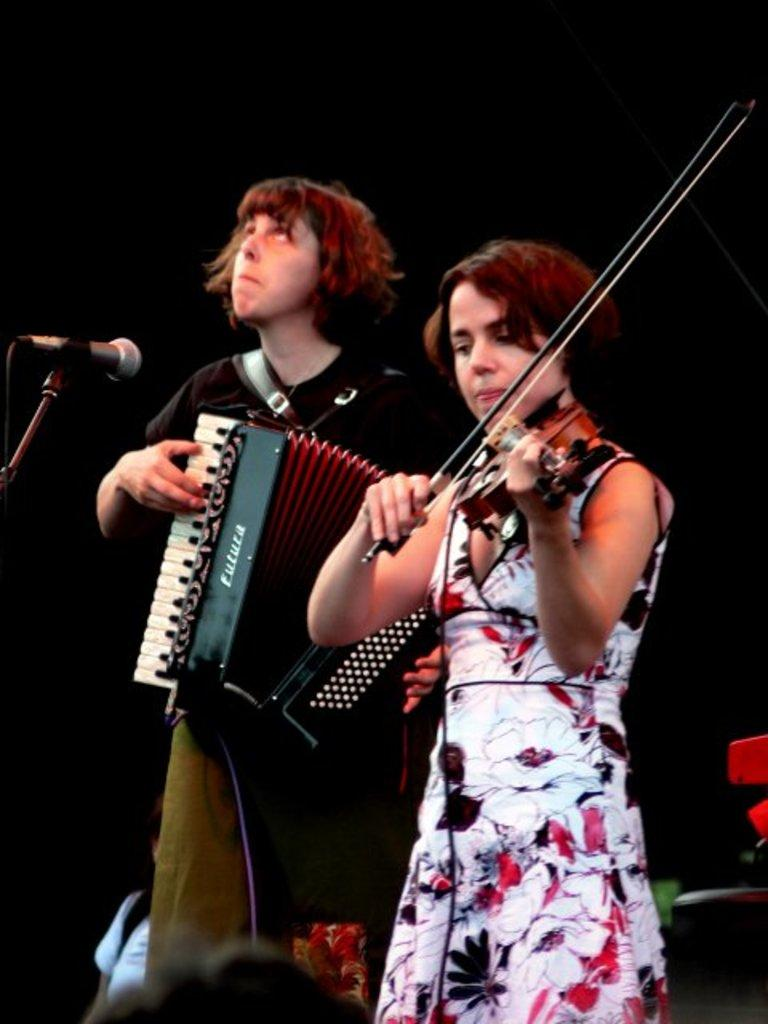How many people are in the image? There are two people in the image. Can you describe the woman in the image? The woman is playing a guitar. What is the man in the image doing? The man is playing a musical instrument. What object is present in the image that is commonly used for amplifying sound? There is a microphone (mic) in the image. What type of wool is the man wearing in the image? There is no wool visible in the image, and the man's clothing is not described in the provided facts. What type of insurance policy is the woman discussing with the man in the image? There is no mention of insurance or any discussion in the image. 